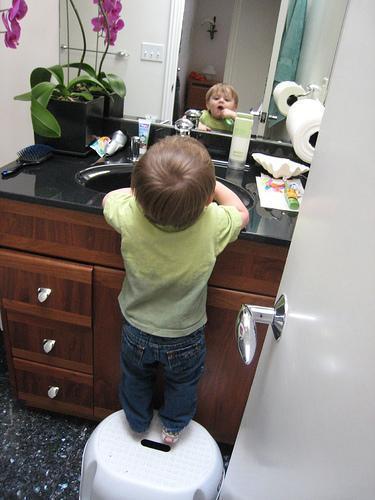How many people are there?
Give a very brief answer. 1. 